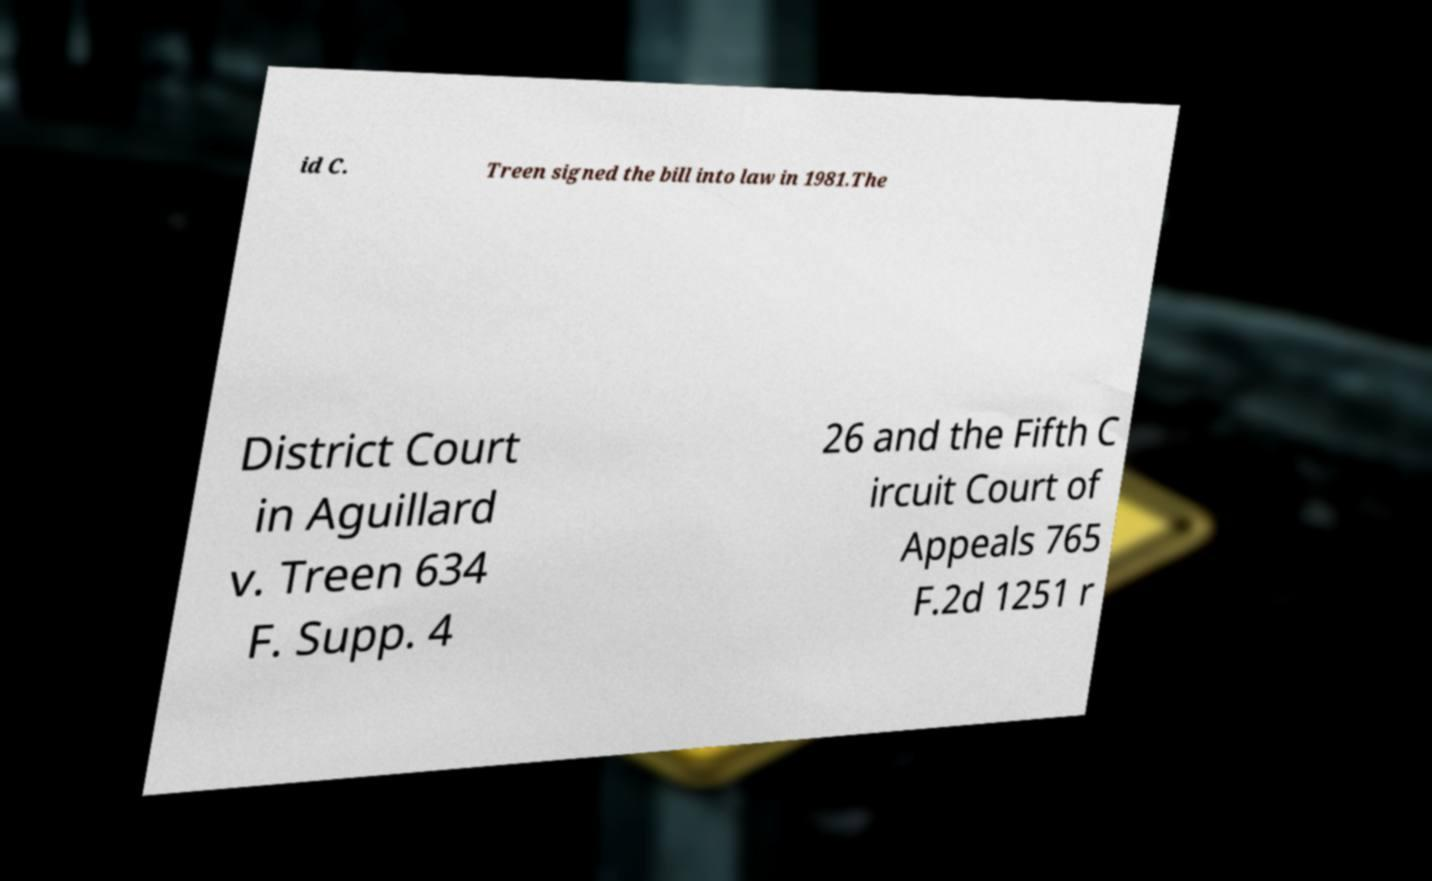Could you assist in decoding the text presented in this image and type it out clearly? id C. Treen signed the bill into law in 1981.The District Court in Aguillard v. Treen 634 F. Supp. 4 26 and the Fifth C ircuit Court of Appeals 765 F.2d 1251 r 